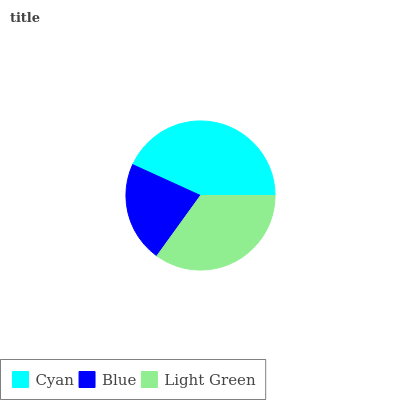Is Blue the minimum?
Answer yes or no. Yes. Is Cyan the maximum?
Answer yes or no. Yes. Is Light Green the minimum?
Answer yes or no. No. Is Light Green the maximum?
Answer yes or no. No. Is Light Green greater than Blue?
Answer yes or no. Yes. Is Blue less than Light Green?
Answer yes or no. Yes. Is Blue greater than Light Green?
Answer yes or no. No. Is Light Green less than Blue?
Answer yes or no. No. Is Light Green the high median?
Answer yes or no. Yes. Is Light Green the low median?
Answer yes or no. Yes. Is Cyan the high median?
Answer yes or no. No. Is Blue the low median?
Answer yes or no. No. 